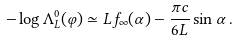Convert formula to latex. <formula><loc_0><loc_0><loc_500><loc_500>- \log \Lambda ^ { 0 } _ { L } ( \varphi ) \simeq L f _ { \infty } ( \alpha ) - \frac { \pi c } { 6 L } \sin \alpha \, .</formula> 